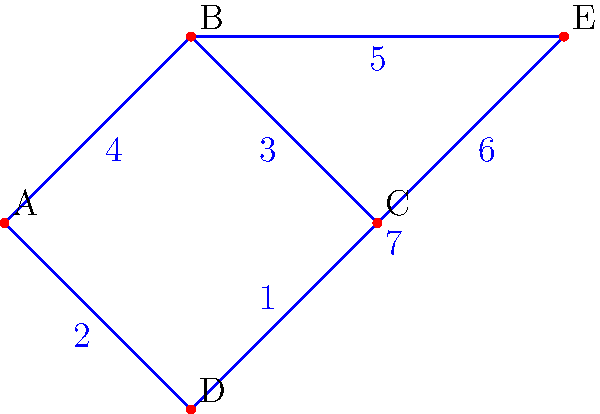As a freelance press release writer, you're analyzing the importance of various news sources for your work. The graph represents different news sources (nodes) and their connections (edges), with weights indicating the strength of their relationships. What is the total weight of the minimum spanning tree for this network of news sources? To find the minimum spanning tree (MST) of this weighted graph, we'll use Kruskal's algorithm:

1. Sort all edges by weight in ascending order:
   CD (1), AD (2), BC (3), AB (4), BE (5), CE (6), DE (7)

2. Start with an empty MST and add edges in order, skipping those that would create a cycle:
   - Add CD (1)
   - Add AD (2)
   - Add BC (3)
   - Skip AB (4) as it would create a cycle
   - Add BE (5)

3. We now have 4 edges in our MST, which is correct for a 5-node tree (n-1 edges where n is the number of nodes).

4. Sum the weights of the edges in the MST:
   $1 + 2 + 3 + 5 = 11$

Therefore, the total weight of the minimum spanning tree is 11.
Answer: 11 